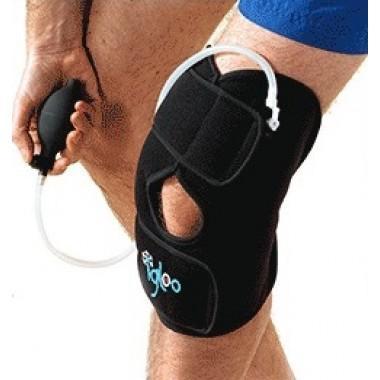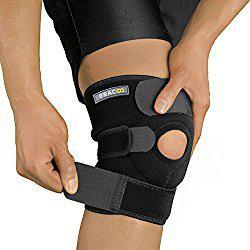The first image is the image on the left, the second image is the image on the right. Examine the images to the left and right. Is the description "One black kneepad with a round knee hole is in each image, one of them being adjusted by a person using two hands." accurate? Answer yes or no. Yes. The first image is the image on the left, the second image is the image on the right. Considering the images on both sides, is "One image shows a hand on the left holding something next to a black knee pad worn on a leg next to a bare leg." valid? Answer yes or no. Yes. 